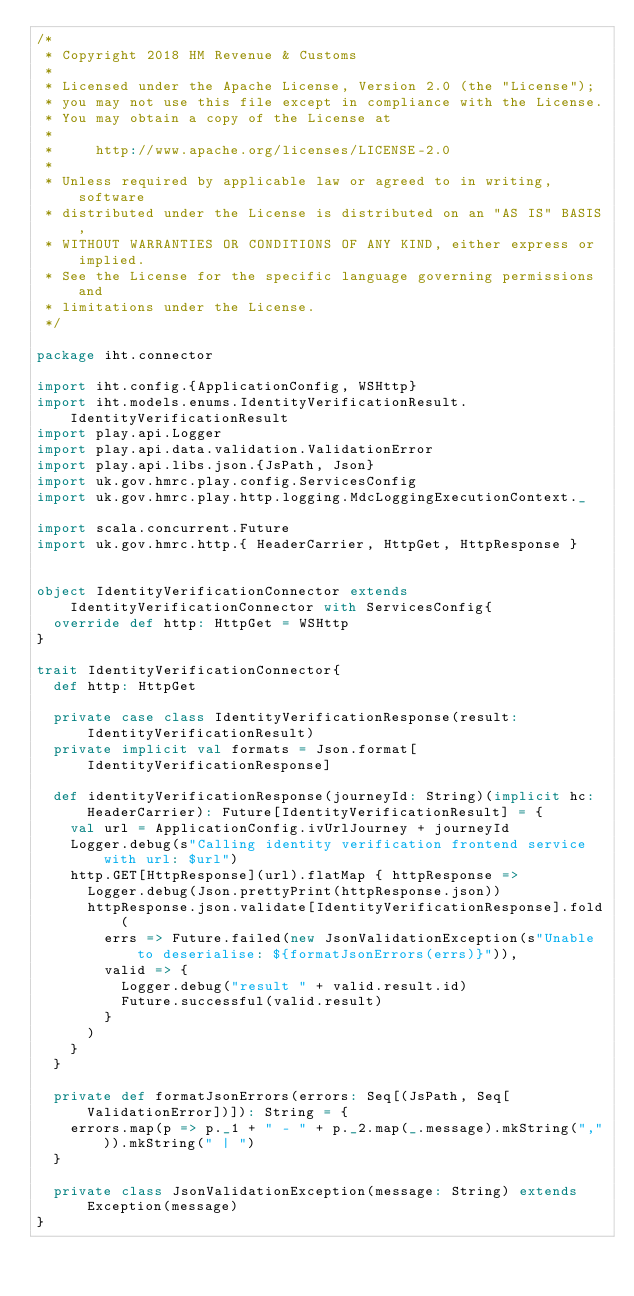Convert code to text. <code><loc_0><loc_0><loc_500><loc_500><_Scala_>/*
 * Copyright 2018 HM Revenue & Customs
 *
 * Licensed under the Apache License, Version 2.0 (the "License");
 * you may not use this file except in compliance with the License.
 * You may obtain a copy of the License at
 *
 *     http://www.apache.org/licenses/LICENSE-2.0
 *
 * Unless required by applicable law or agreed to in writing, software
 * distributed under the License is distributed on an "AS IS" BASIS,
 * WITHOUT WARRANTIES OR CONDITIONS OF ANY KIND, either express or implied.
 * See the License for the specific language governing permissions and
 * limitations under the License.
 */

package iht.connector

import iht.config.{ApplicationConfig, WSHttp}
import iht.models.enums.IdentityVerificationResult.IdentityVerificationResult
import play.api.Logger
import play.api.data.validation.ValidationError
import play.api.libs.json.{JsPath, Json}
import uk.gov.hmrc.play.config.ServicesConfig
import uk.gov.hmrc.play.http.logging.MdcLoggingExecutionContext._

import scala.concurrent.Future
import uk.gov.hmrc.http.{ HeaderCarrier, HttpGet, HttpResponse }


object IdentityVerificationConnector extends IdentityVerificationConnector with ServicesConfig{
  override def http: HttpGet = WSHttp
}

trait IdentityVerificationConnector{
  def http: HttpGet

  private case class IdentityVerificationResponse(result: IdentityVerificationResult)
  private implicit val formats = Json.format[IdentityVerificationResponse]

  def identityVerificationResponse(journeyId: String)(implicit hc: HeaderCarrier): Future[IdentityVerificationResult] = {
    val url = ApplicationConfig.ivUrlJourney + journeyId
    Logger.debug(s"Calling identity verification frontend service with url: $url")
    http.GET[HttpResponse](url).flatMap { httpResponse =>
      Logger.debug(Json.prettyPrint(httpResponse.json))
      httpResponse.json.validate[IdentityVerificationResponse].fold(
        errs => Future.failed(new JsonValidationException(s"Unable to deserialise: ${formatJsonErrors(errs)}")),
        valid => {
          Logger.debug("result " + valid.result.id)
          Future.successful(valid.result)
        }
      )
    }
  }

  private def formatJsonErrors(errors: Seq[(JsPath, Seq[ValidationError])]): String = {
    errors.map(p => p._1 + " - " + p._2.map(_.message).mkString(",")).mkString(" | ")
  }

  private class JsonValidationException(message: String) extends Exception(message)
}
</code> 